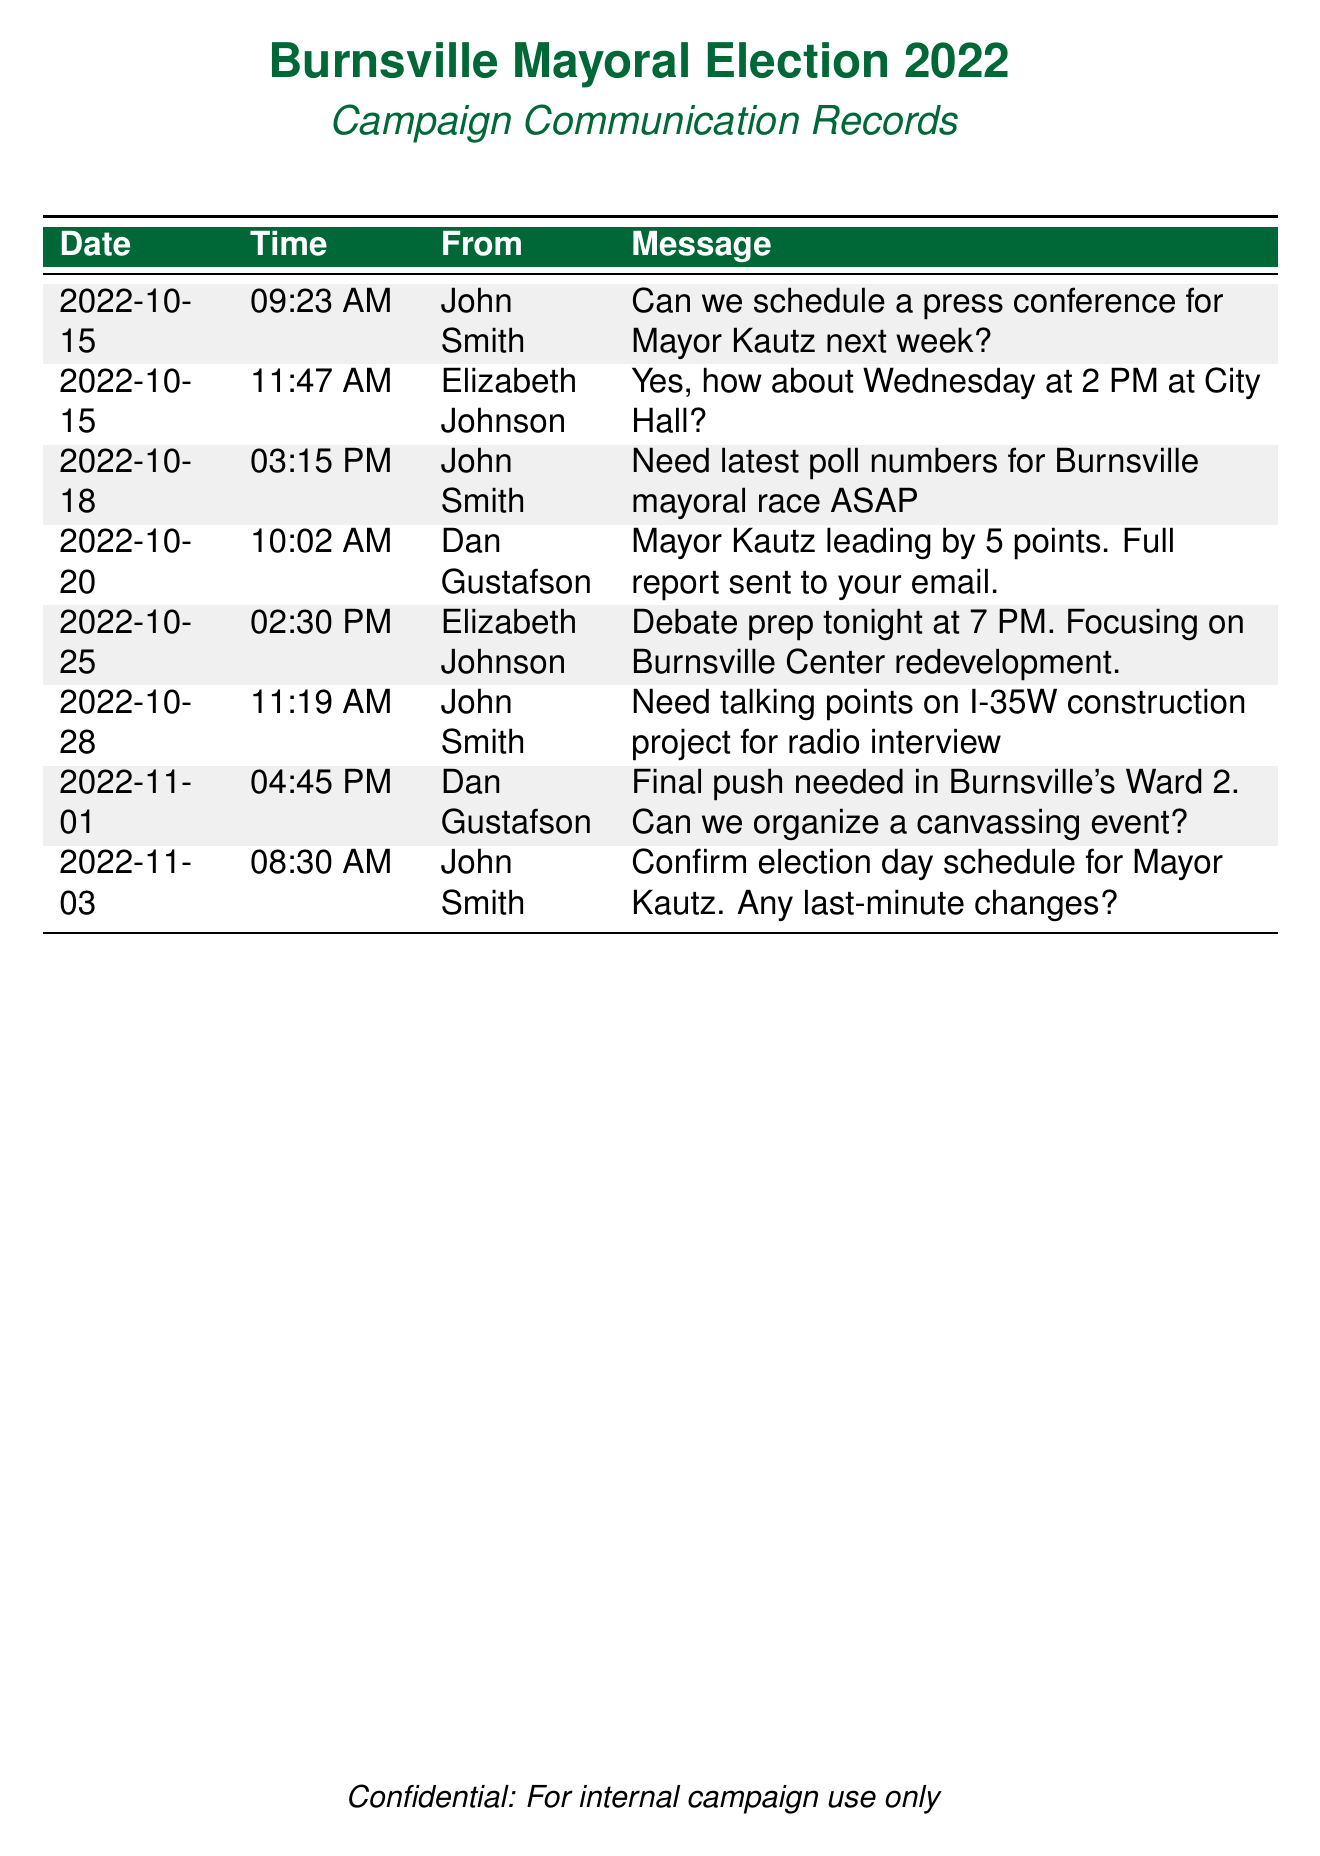What is the date of the first message? The first message in the document is dated October 15, 2022.
Answer: October 15, 2022 Who sent the message about the debate prep? The message regarding debate preparation was sent by Elizabeth Johnson.
Answer: Elizabeth Johnson What time was the last message sent? The last message in the provided records was sent at 8:30 AM on November 3, 2022.
Answer: 08:30 AM How many days before the election was the press conference scheduled? The election date is not provided, but based on the context, the election is likely on November 8, 2022, making the press conference scheduled 23 days before.
Answer: 23 What topic was the debate prep focusing on? The debate preparation focused on the Burnsville Center redevelopment.
Answer: Burnsville Center redevelopment Who confirmed the election day schedule for Mayor Kautz? The confirmation about the election day schedule was made by John Smith.
Answer: John Smith What message was sent at 10:02 AM on October 28? The message sent at that time was a request for talking points on the I-35W construction project.
Answer: Need talking points on I-35W construction project for radio interview How many points is Mayor Kautz leading by according to Dan Gustafson? Dan Gustafson indicated that Mayor Kautz is leading by 5 points.
Answer: 5 points 